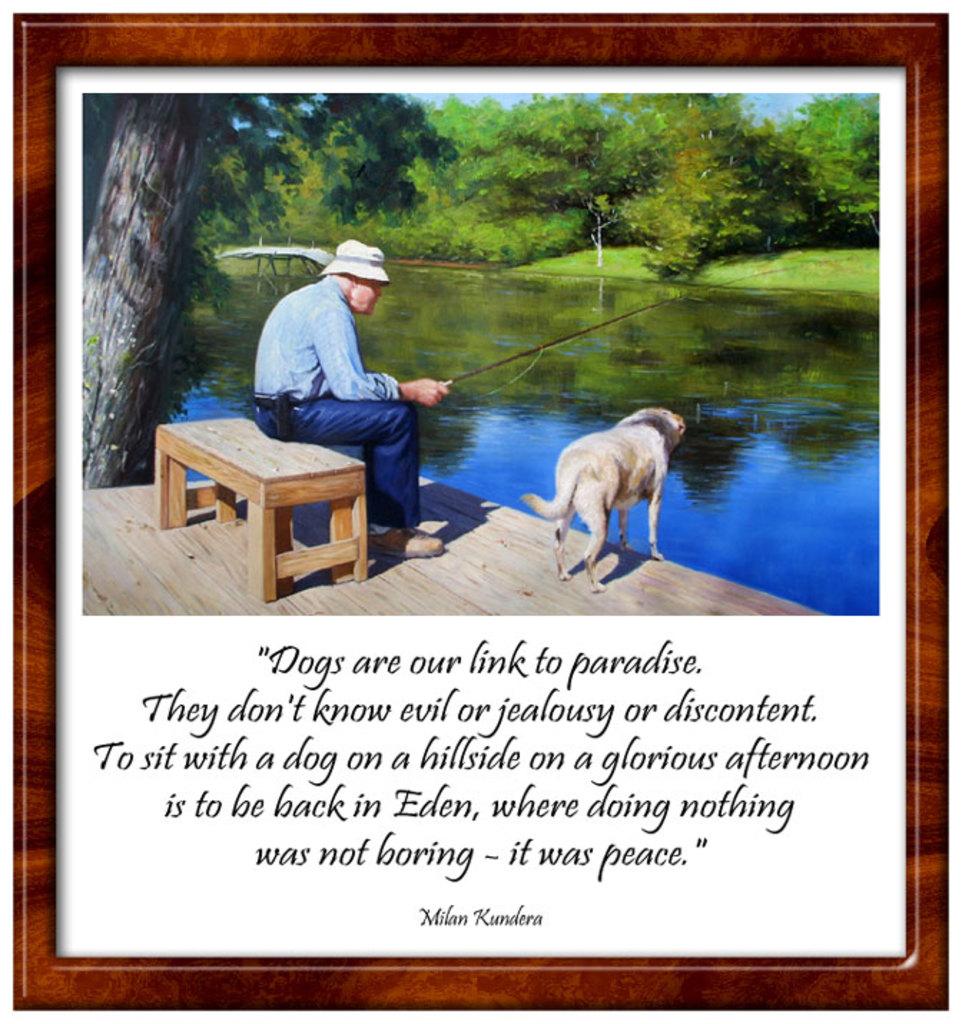Who wrote the quote that starts with "dogs are our link to paradise"?
Your answer should be compact. Milan kundera. Dogs don't know what?
Offer a very short reply. Evil or jealousy or discontent. 